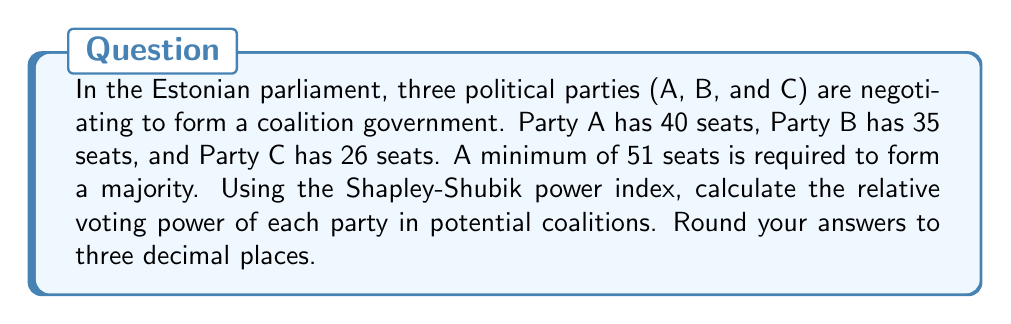Provide a solution to this math problem. To solve this problem, we'll use the Shapley-Shubik power index, which measures the relative power of each player in a voting game. The steps are as follows:

1. Identify all possible winning coalitions:
   AB (75 seats), AC (66 seats), ABC (101 seats)

2. List all possible orderings of parties:
   ABC, ACB, BAC, BCA, CAB, CBA

3. For each ordering, identify the pivotal player (the one that turns a losing coalition into a winning one):
   ABC: B is pivotal
   ACB: A is pivotal
   BAC: A is pivotal
   BCA: B is pivotal
   CAB: A is pivotal
   CBA: A is pivotal

4. Count the number of times each party is pivotal:
   Party A: 4 times
   Party B: 2 times
   Party C: 0 times

5. Calculate the Shapley-Shubik power index:
   $$\text{Power index} = \frac{\text{Number of times party is pivotal}}{\text{Total number of orderings}}$$

   For Party A: $$\frac{4}{6} = 0.667$$
   For Party B: $$\frac{2}{6} = 0.333$$
   For C: $$\frac{0}{6} = 0.000$$

The Shapley-Shubik power index shows that despite having fewer seats than the sum of B and C, Party A has the most relative voting power in potential coalitions.
Answer: Party A: 0.667
Party B: 0.333
Party C: 0.000 